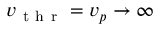Convert formula to latex. <formula><loc_0><loc_0><loc_500><loc_500>v _ { t h r } = v _ { p } \to \infty</formula> 